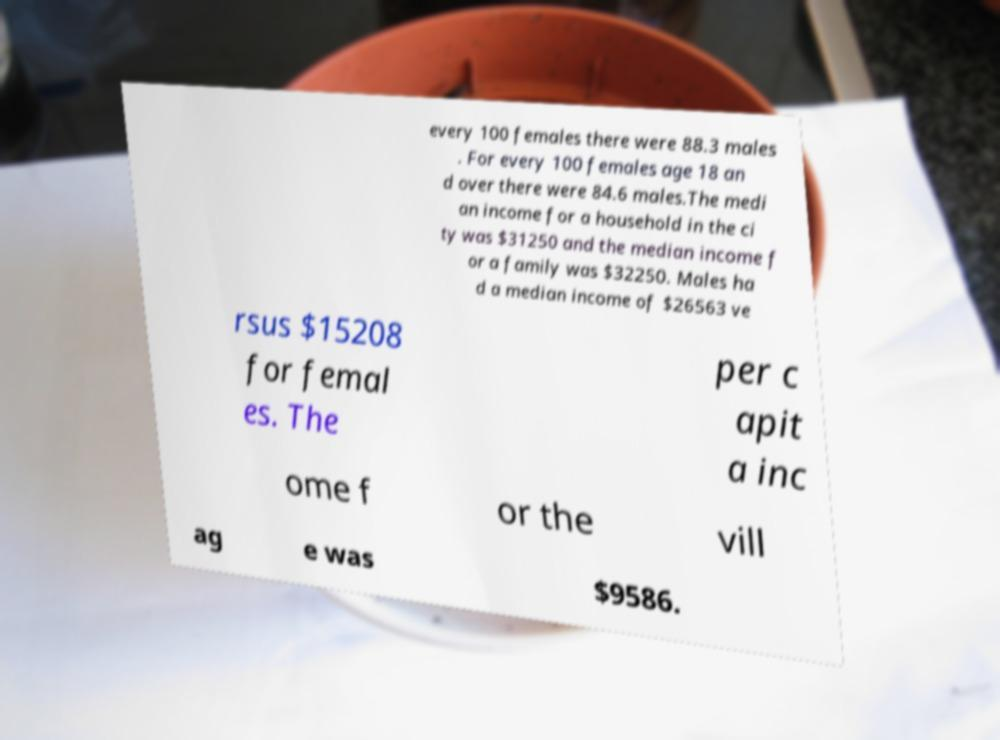There's text embedded in this image that I need extracted. Can you transcribe it verbatim? every 100 females there were 88.3 males . For every 100 females age 18 an d over there were 84.6 males.The medi an income for a household in the ci ty was $31250 and the median income f or a family was $32250. Males ha d a median income of $26563 ve rsus $15208 for femal es. The per c apit a inc ome f or the vill ag e was $9586. 